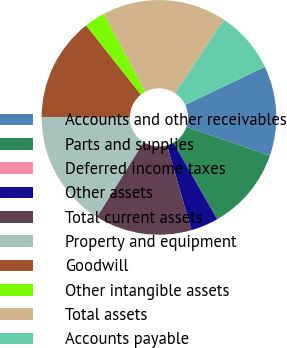<chart> <loc_0><loc_0><loc_500><loc_500><pie_chart><fcel>Accounts and other receivables<fcel>Parts and supplies<fcel>Deferred income taxes<fcel>Other assets<fcel>Total current assets<fcel>Property and equipment<fcel>Goodwill<fcel>Other intangible assets<fcel>Total assets<fcel>Accounts payable<nl><fcel>12.38%<fcel>11.43%<fcel>0.01%<fcel>3.81%<fcel>13.33%<fcel>16.19%<fcel>14.28%<fcel>2.86%<fcel>17.14%<fcel>8.57%<nl></chart> 